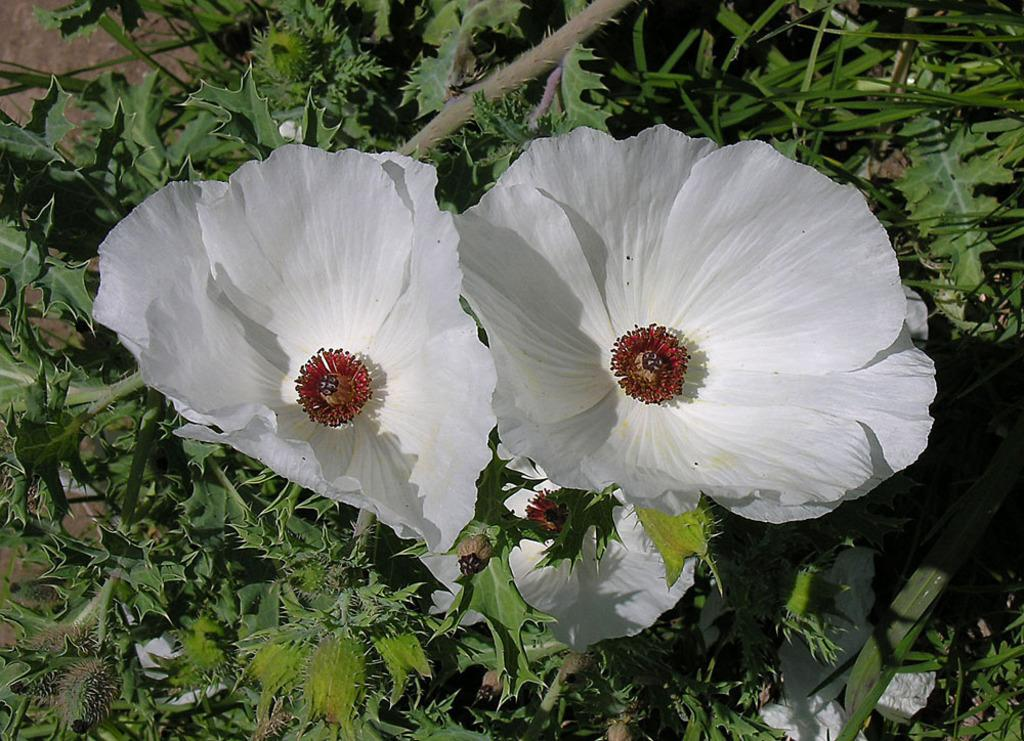What type of flora can be seen in the image? There are flowers in the image. What color are the flowers? The flowers are white. What is the color of the pollen grains on the flowers? The pollen grains are red. What other types of plants are present at the bottom of the image? There are plants and trees at the bottom of the image. What type of apparel is the flower wearing in the image? Flowers do not wear apparel, so this question cannot be answered. 